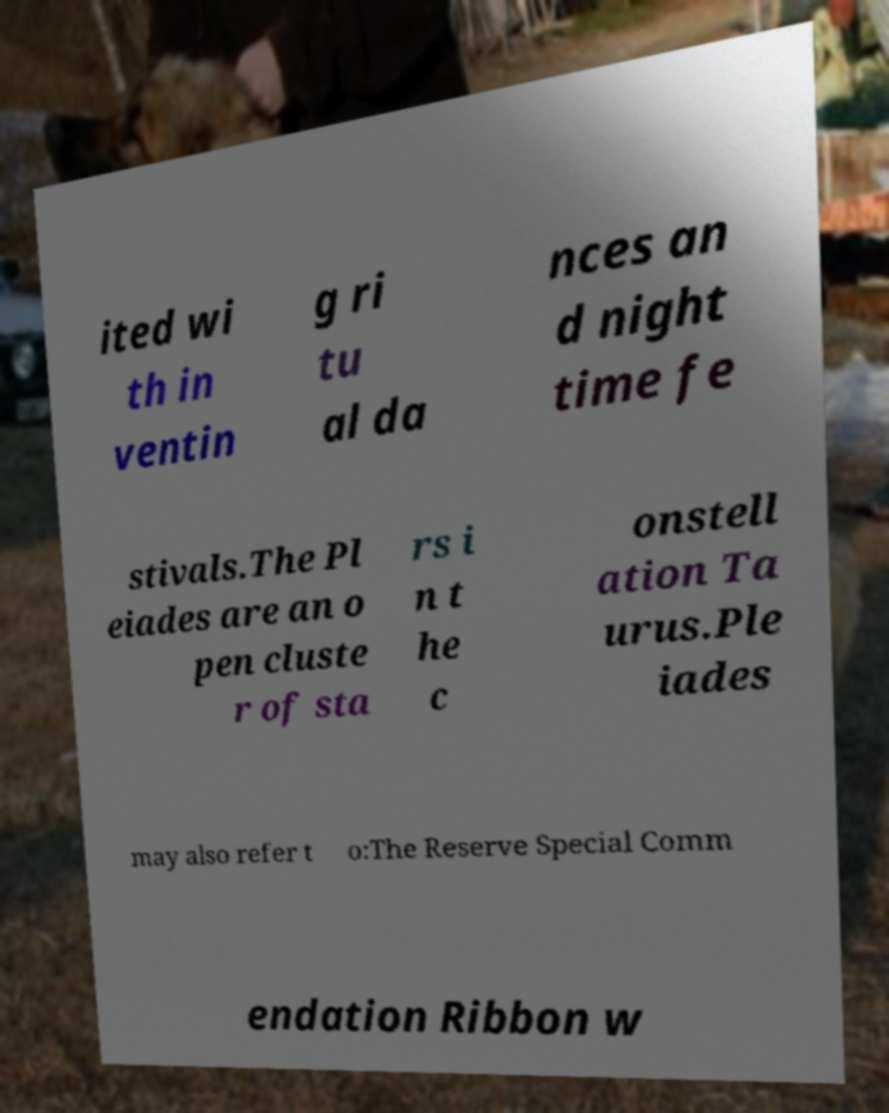Could you assist in decoding the text presented in this image and type it out clearly? ited wi th in ventin g ri tu al da nces an d night time fe stivals.The Pl eiades are an o pen cluste r of sta rs i n t he c onstell ation Ta urus.Ple iades may also refer t o:The Reserve Special Comm endation Ribbon w 